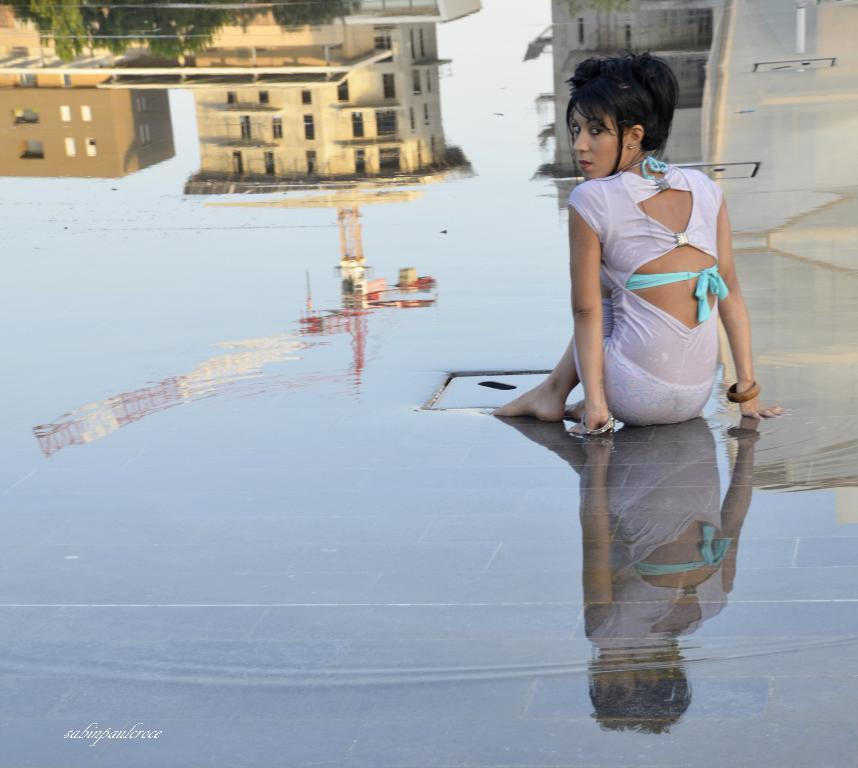Who is the main subject in the image? There is a girl in the image. What is the girl sitting on? The girl is sitting on a wet surface. What is the girl wearing? The girl is wearing a white dress. What can be seen in the reflections in the image? There are reflections of buildings and trees in the image. Where are the reflections located? The reflections are on the water. Can you see a tiger walking on the sand in the image? No, there is no tiger or sand present in the image. How many ants are crawling on the girl's dress in the image? There are no ants visible on the girl's dress in the image. 